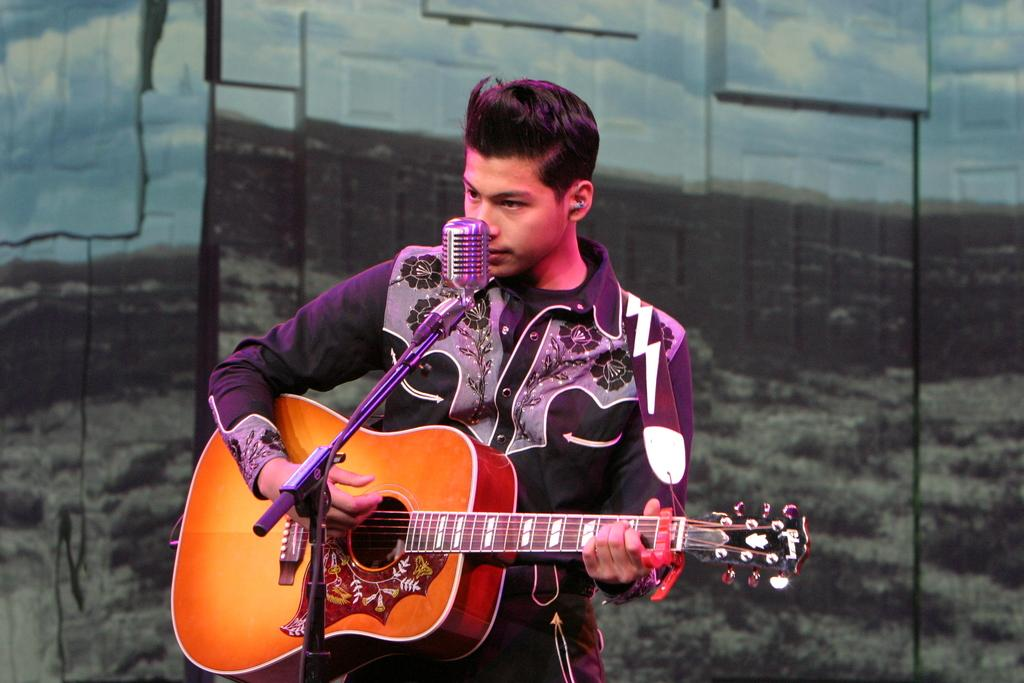Who is the main subject in the image? There is a boy in the image. What is the boy doing in the image? The boy is playing the guitar and singing a song. What object is the boy using to amplify his voice? The boy is in front of a microphone. What can be seen in the background of the image? There is a poster in the background of the image. What type of brake can be seen on the guitar in the image? There is no brake present on the guitar in the image. How many marks are visible on the poster in the background? The provided facts do not mention any marks on the poster, so we cannot determine the number of marks from the image. 